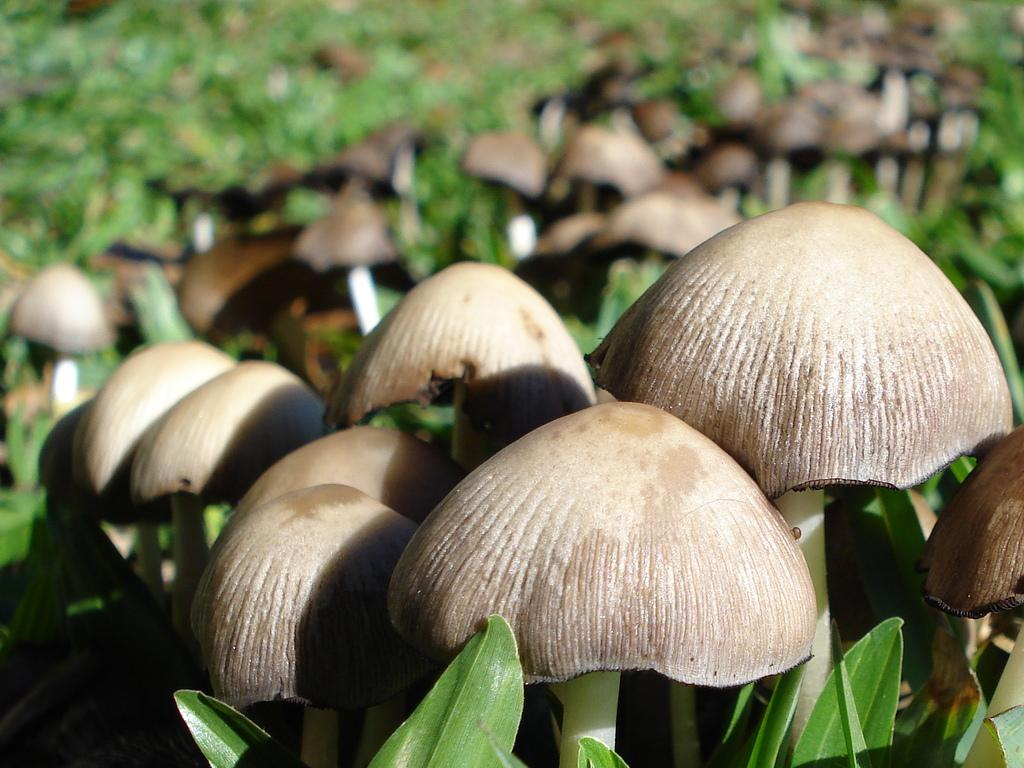What type of fungi can be seen in the image? There are many mushrooms in the image. Where are the mushrooms located? The mushrooms are in between the grass. What type of kitten can be seen playing with knowledge in the image? There is no kitten or knowledge present in the image; it only features mushrooms in between the grass. 